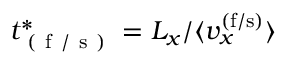Convert formula to latex. <formula><loc_0><loc_0><loc_500><loc_500>t _ { ( f / s ) } ^ { * } = L _ { x } / \langle v _ { x } ^ { ( f / s ) } \rangle</formula> 